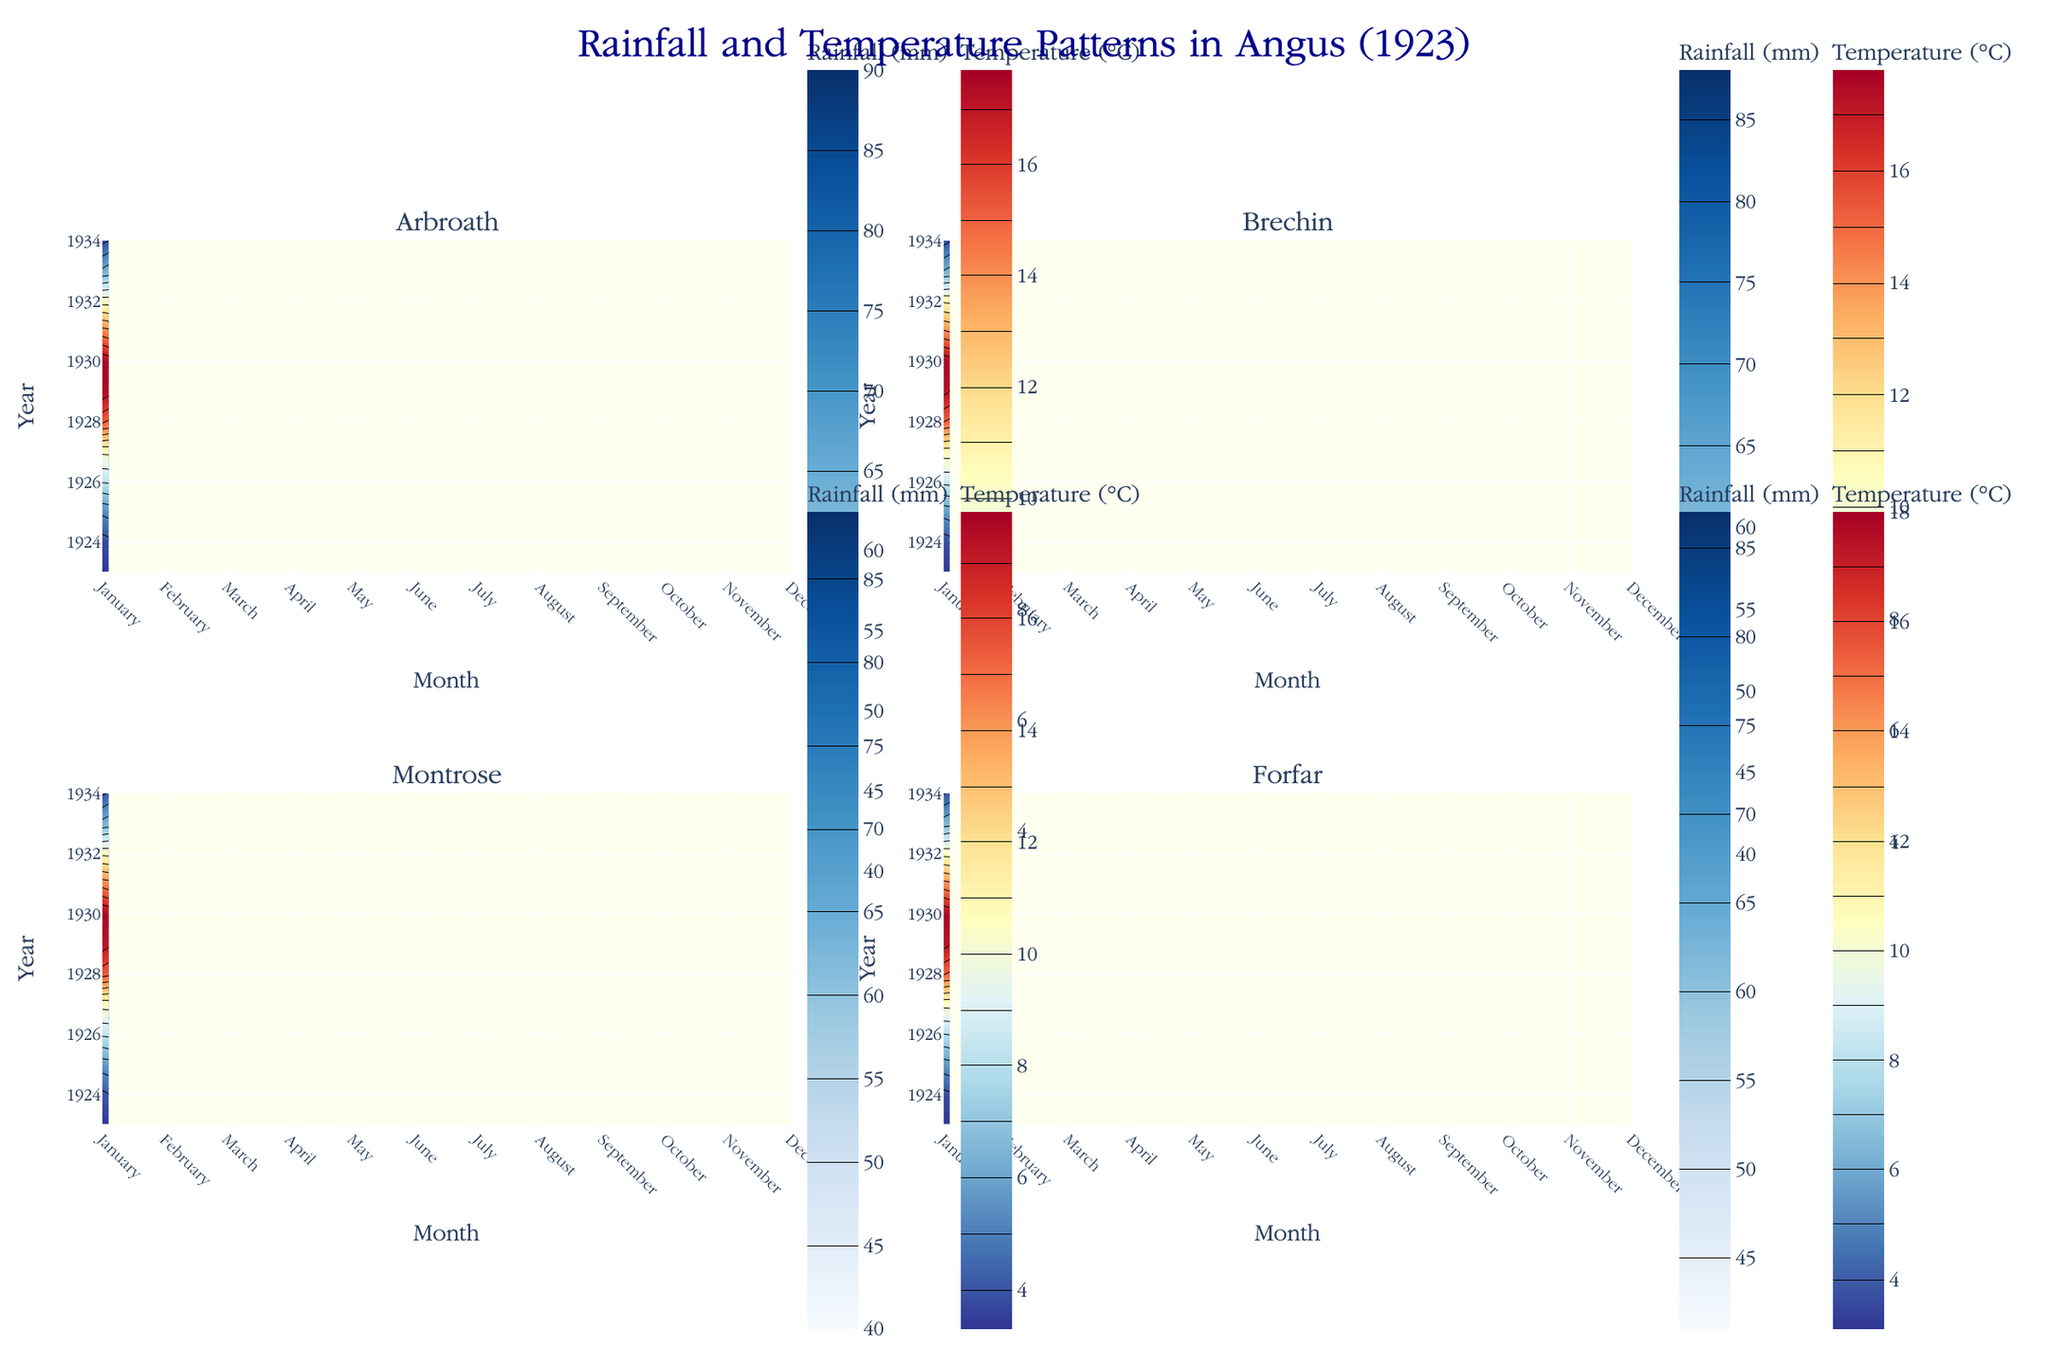What are the subplot titles in the figure? The titles of the subplots represent the different regions in Angus for which the data is visualized. They are visible at the top of each subplot box.
Answer: Arbroath, Brechin, Montrose, Forfar How many data points are represented for each region per year? Each subplot shows monthly data for one year, so there are 12 data points for each region.
Answer: 12 Which color scale is used to represent rainfall in the figure? The color scale used for rainfall is visually represented by shades of blue in the figure.
Answer: Blues Does Montrose have a higher August temperature than July? By examining the color intensity in the contour map for Montrose, the August grid shows a slightly different color than July, which signifies a slightly higher temperature.
Answer: Yes What is the title of the figure that encompasses all the subplots? The figure title is positioned at the top center of the figure, providing an overview of what the subplots detail.
Answer: Rainfall and Temperature Patterns in Angus (1923) Which region shows the highest temperature in August? By comparing the contour maps for August in all the subplots, the area with the most intense red (indicating highest temperature) represents the region with the highest temperature.
Answer: Montrose Compare the rainfall in June between Arbroath and Brechin. Which region has more rainfall? Viewing the contour levels in the respective subplots for June, compare the colors to see which region has darker blue, indicating more rainfall.
Answer: Arbroath During which month does Forfar experience the lowest temperature? The lowest temperature corresponds to the deepest blue in the contour plot for Forfar. This can be found by looking for the darkest area in the temperature contour map.
Answer: January Sum the rainfall of Arbroath for the first quarter of the year (January, February, and March). Sum the rainfall values for January, February, and March from the subplot corresponding to Arbroath. 45 + 38 + 55 = 138 mm
Answer: 138 mm Which region has the most consistent temperature across the months? The most consistent temperature will have the least variation in color intensity in the contour map. Evaluate the smoothness of the color transitions across the months.
Answer: Brechin 